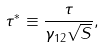Convert formula to latex. <formula><loc_0><loc_0><loc_500><loc_500>\tau ^ { * } \equiv \frac { \tau } { \gamma _ { 1 2 } \sqrt { S } } ,</formula> 